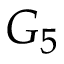Convert formula to latex. <formula><loc_0><loc_0><loc_500><loc_500>G _ { 5 }</formula> 